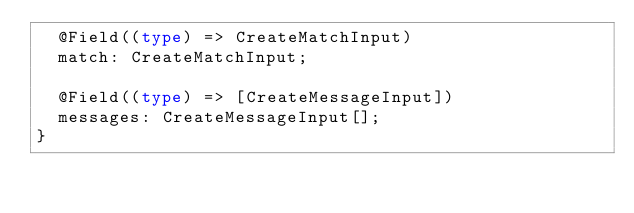<code> <loc_0><loc_0><loc_500><loc_500><_TypeScript_>  @Field((type) => CreateMatchInput)
  match: CreateMatchInput;

  @Field((type) => [CreateMessageInput])
  messages: CreateMessageInput[];
}
</code> 